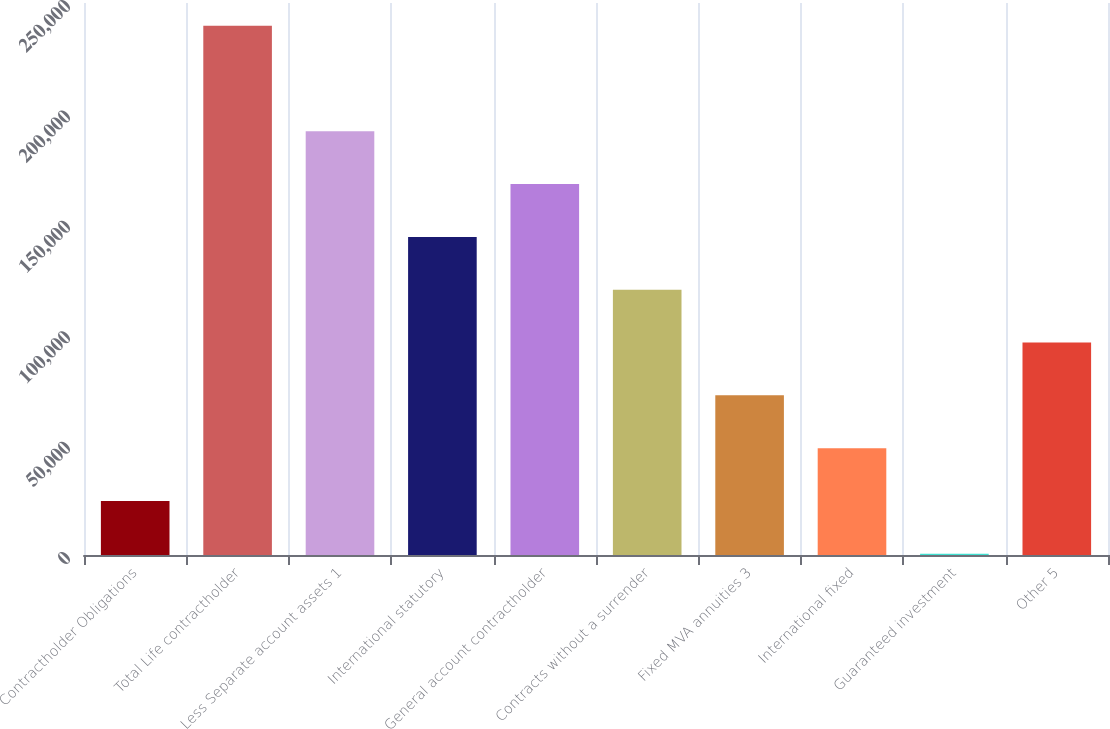Convert chart to OTSL. <chart><loc_0><loc_0><loc_500><loc_500><bar_chart><fcel>Contractholder Obligations<fcel>Total Life contractholder<fcel>Less Separate account assets 1<fcel>International statutory<fcel>General account contractholder<fcel>Contracts without a surrender<fcel>Fixed MVA annuities 3<fcel>International fixed<fcel>Guaranteed investment<fcel>Other 5<nl><fcel>24482.6<fcel>239723<fcel>191892<fcel>144061<fcel>167976<fcel>120145<fcel>72313.8<fcel>48398.2<fcel>567<fcel>96229.4<nl></chart> 